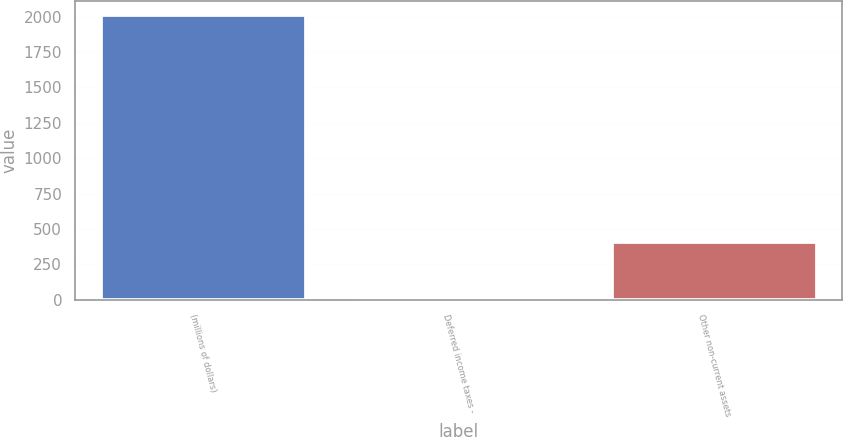<chart> <loc_0><loc_0><loc_500><loc_500><bar_chart><fcel>(millions of dollars)<fcel>Deferred income taxes -<fcel>Other non-current assets<nl><fcel>2011<fcel>6.5<fcel>407.4<nl></chart> 